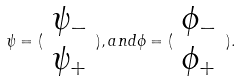<formula> <loc_0><loc_0><loc_500><loc_500>\psi = ( \begin{array} { c } \psi _ { - } \\ \psi _ { + } \end{array} ) , a n d \phi = ( \begin{array} { c } \phi _ { - } \\ \phi _ { + } \end{array} ) .</formula> 